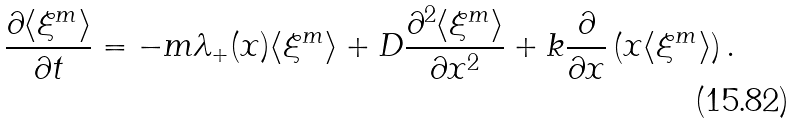Convert formula to latex. <formula><loc_0><loc_0><loc_500><loc_500>\frac { \partial \langle \xi ^ { m } \rangle } { \partial t } = - m \lambda _ { + } ( x ) \langle \xi ^ { m } \rangle + D \frac { \partial ^ { 2 } \langle \xi ^ { m } \rangle } { \partial x ^ { 2 } } + k \frac { \partial } { \partial x } \left ( x \langle \xi ^ { m } \rangle \right ) .</formula> 